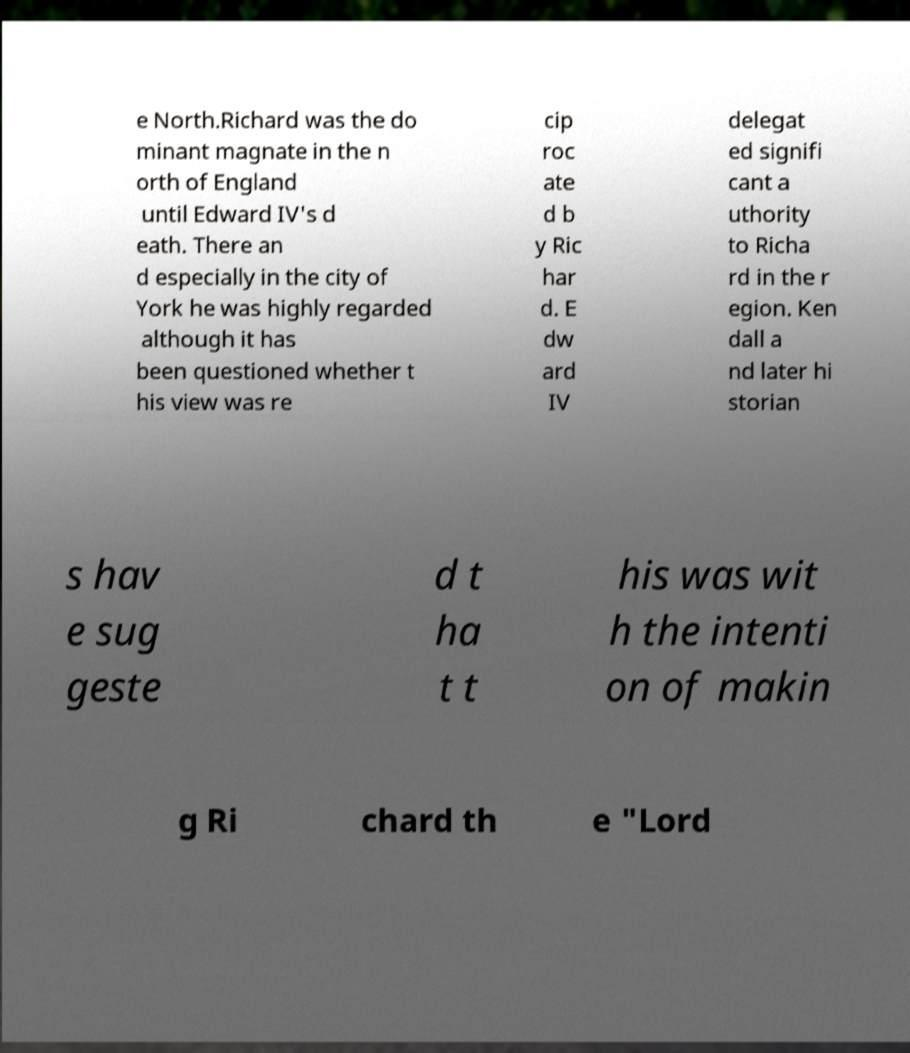Please identify and transcribe the text found in this image. e North.Richard was the do minant magnate in the n orth of England until Edward IV's d eath. There an d especially in the city of York he was highly regarded although it has been questioned whether t his view was re cip roc ate d b y Ric har d. E dw ard IV delegat ed signifi cant a uthority to Richa rd in the r egion. Ken dall a nd later hi storian s hav e sug geste d t ha t t his was wit h the intenti on of makin g Ri chard th e "Lord 